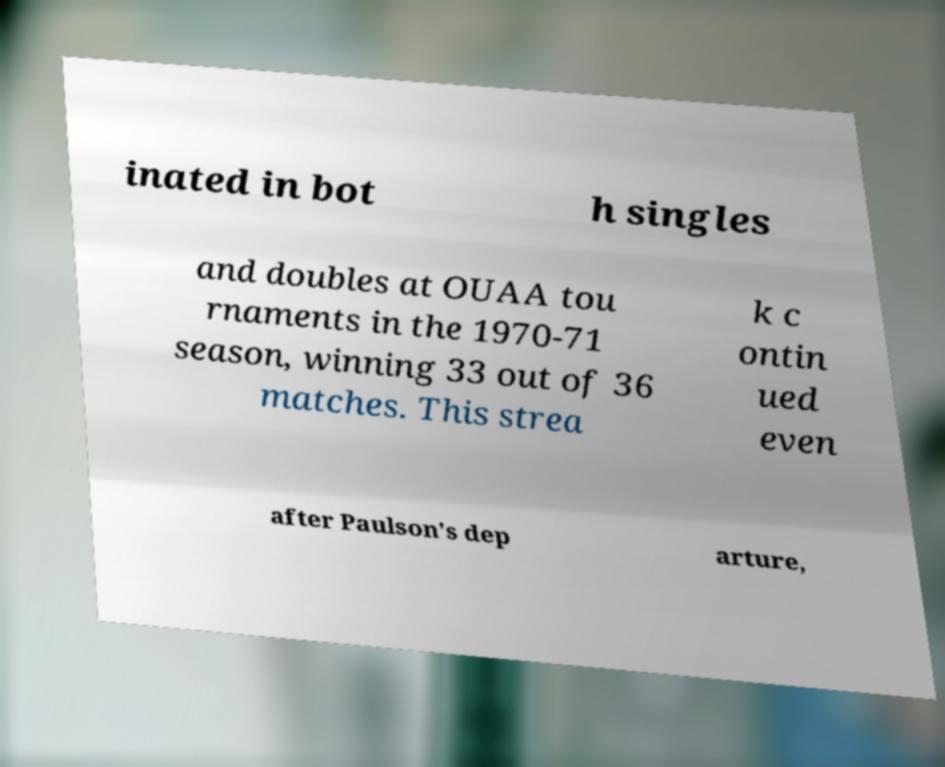Can you accurately transcribe the text from the provided image for me? inated in bot h singles and doubles at OUAA tou rnaments in the 1970-71 season, winning 33 out of 36 matches. This strea k c ontin ued even after Paulson's dep arture, 